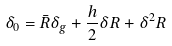Convert formula to latex. <formula><loc_0><loc_0><loc_500><loc_500>\delta _ { 0 } = \bar { R } \delta _ { g } + \frac { h } { 2 } \delta R + \delta ^ { 2 } R</formula> 